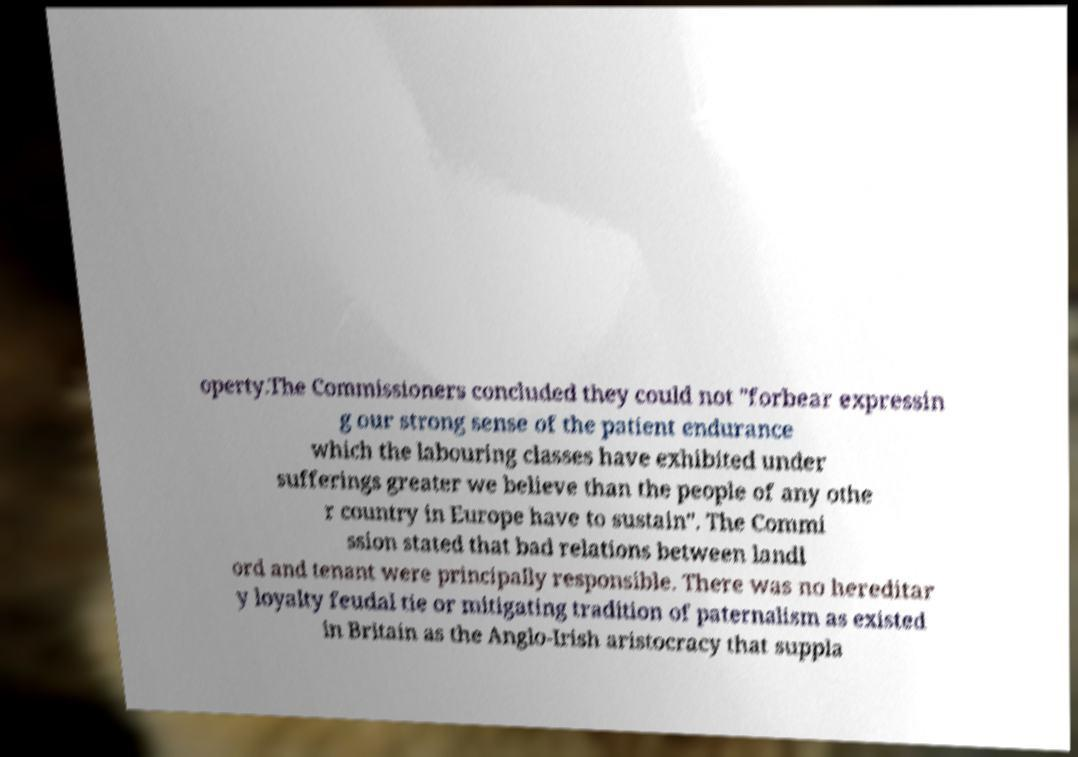Please identify and transcribe the text found in this image. operty.The Commissioners concluded they could not "forbear expressin g our strong sense of the patient endurance which the labouring classes have exhibited under sufferings greater we believe than the people of any othe r country in Europe have to sustain". The Commi ssion stated that bad relations between landl ord and tenant were principally responsible. There was no hereditar y loyalty feudal tie or mitigating tradition of paternalism as existed in Britain as the Anglo-Irish aristocracy that suppla 